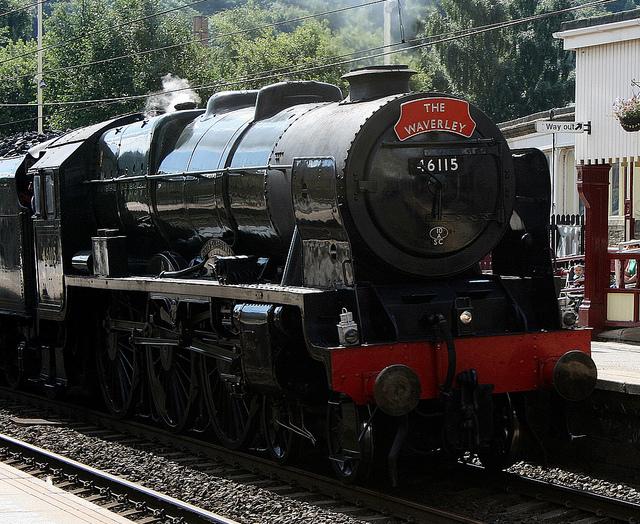Is the train moving?
Answer briefly. No. What does it say on the front of the train?
Write a very short answer. Waverley. What are the numbers on the train?
Short answer required. 6115. What color is most of this train?
Write a very short answer. Black. What is the name of the train?
Short answer required. Waverley. What does the front of the train say?
Answer briefly. Waverley. 